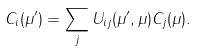Convert formula to latex. <formula><loc_0><loc_0><loc_500><loc_500>C _ { i } ( \mu ^ { \prime } ) = \sum _ { j } U _ { i j } ( \mu ^ { \prime } , \mu ) C _ { j } ( \mu ) .</formula> 